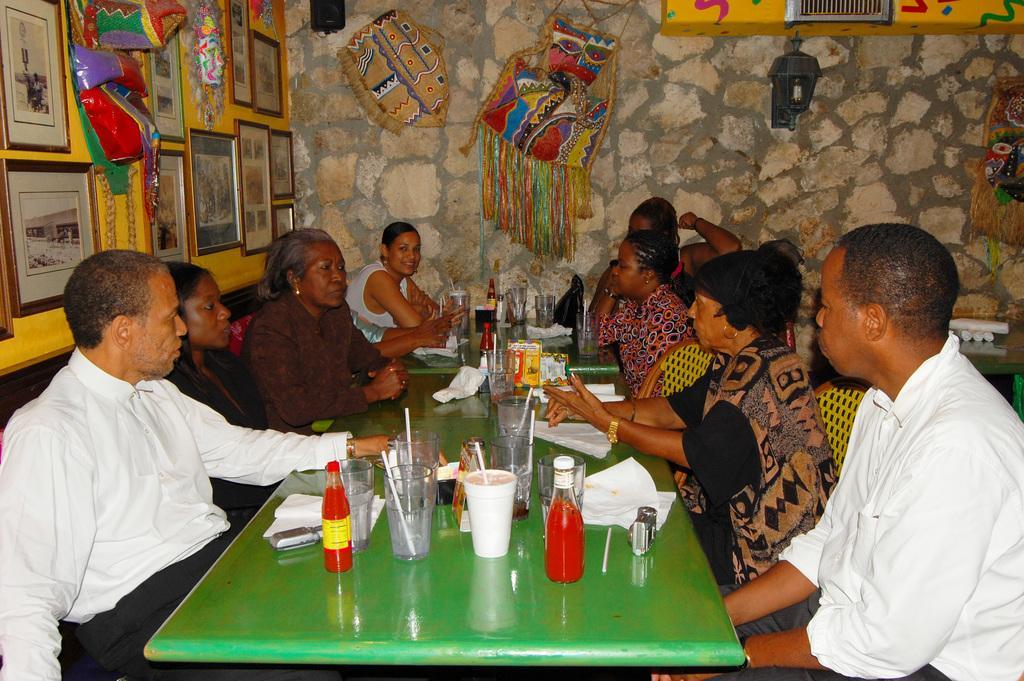Please provide a concise description of this image. In this image I can see a group of people are sitting on a chair in front of a table. On the table I can see few glasses, bottles and other objects on it. I can also see there are two photos and other objects on the wall. 